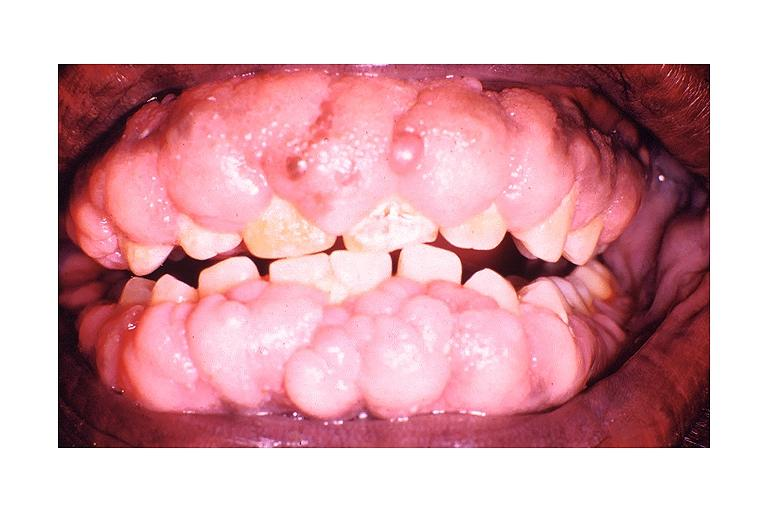where is this?
Answer the question using a single word or phrase. Oral 